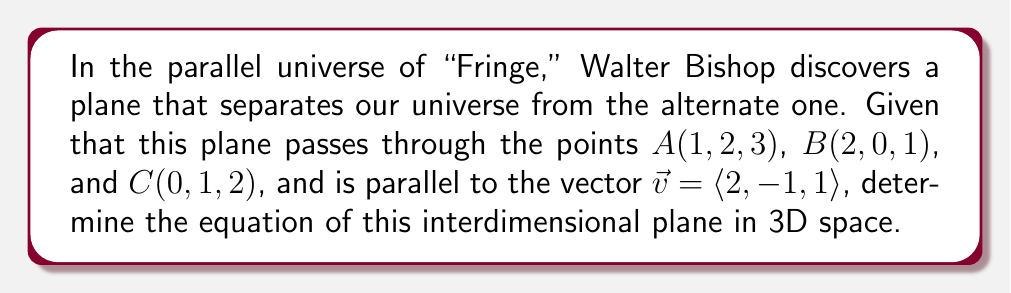Give your solution to this math problem. To find the equation of the plane, we'll follow these steps:

1) First, we need to find two vectors on the plane. We can do this by subtracting the coordinates of point A from B and C:

   $\vec{AB} = \langle 2-1, 0-2, 1-3 \rangle = \langle 1, -2, -2 \rangle$
   $\vec{AC} = \langle 0-1, 1-2, 2-3 \rangle = \langle -1, -1, -1 \rangle$

2) The normal vector to the plane will be perpendicular to both $\vec{AB}$ and $\vec{AC}$. We can find this using the cross product:

   $\vec{n} = \vec{AB} \times \vec{AC} = \begin{vmatrix} 
   i & j & k \\
   1 & -2 & -2 \\
   -1 & -1 & -1
   \end{vmatrix}$

   $= ((-2)(-1) - (-2)(-1))i - (1(-1) - (-2)(-1))j + (1(-1) - (-2)(-1))k$
   
   $= 0i + 1j + 3k = \langle 0, 1, 3 \rangle$

3) Now, we need to check if this normal vector is perpendicular to $\vec{v}$. If it is, we can use it. If not, we need to adjust:

   $\vec{n} \cdot \vec{v} = 0(2) + 1(-1) + 3(1) = 2 \neq 0$

   Since this dot product is not zero, $\vec{n}$ is not perpendicular to $\vec{v}$. We need to find a vector perpendicular to both $\vec{v}$ and $\vec{n}$:

   $\vec{n'} = \vec{n} \times \vec{v} = \begin{vmatrix}
   i & j & k \\
   0 & 1 & 3 \\
   2 & -1 & 1
   \end{vmatrix}$

   $= (1(1) - 3(-1))i - (0(1) - 3(2))j + (0(-1) - 1(2))k$
   
   $= 4i - 6j - 2k = \langle 4, -6, -2 \rangle$

4) Now we have the normal vector to our plane. We can use the point-normal form of a plane equation:

   $4(x-1) - 6(y-2) - 2(z-3) = 0$

5) Simplifying:

   $4x - 4 - 6y + 12 - 2z + 6 = 0$
   $4x - 6y - 2z + 14 = 0$

This is the equation of the interdimensional plane.
Answer: $4x - 6y - 2z + 14 = 0$ 